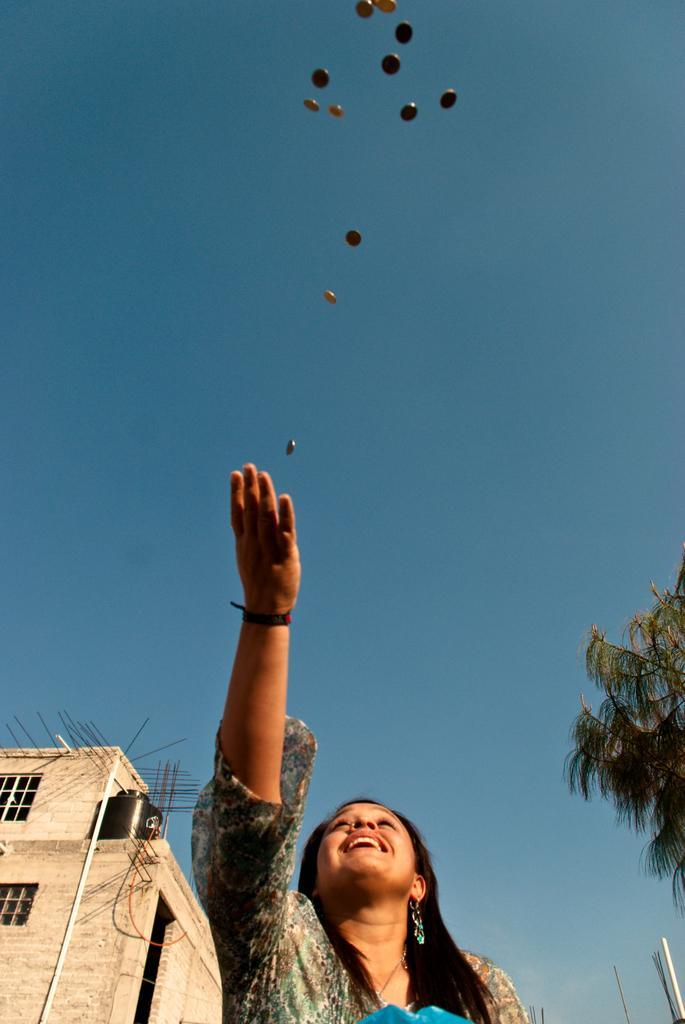Please provide a concise description of this image. In this picture I can see there is a woman, she is smiling and there are few coins in the air, there is a building at left and a tree at the right side. The sky is clear. 